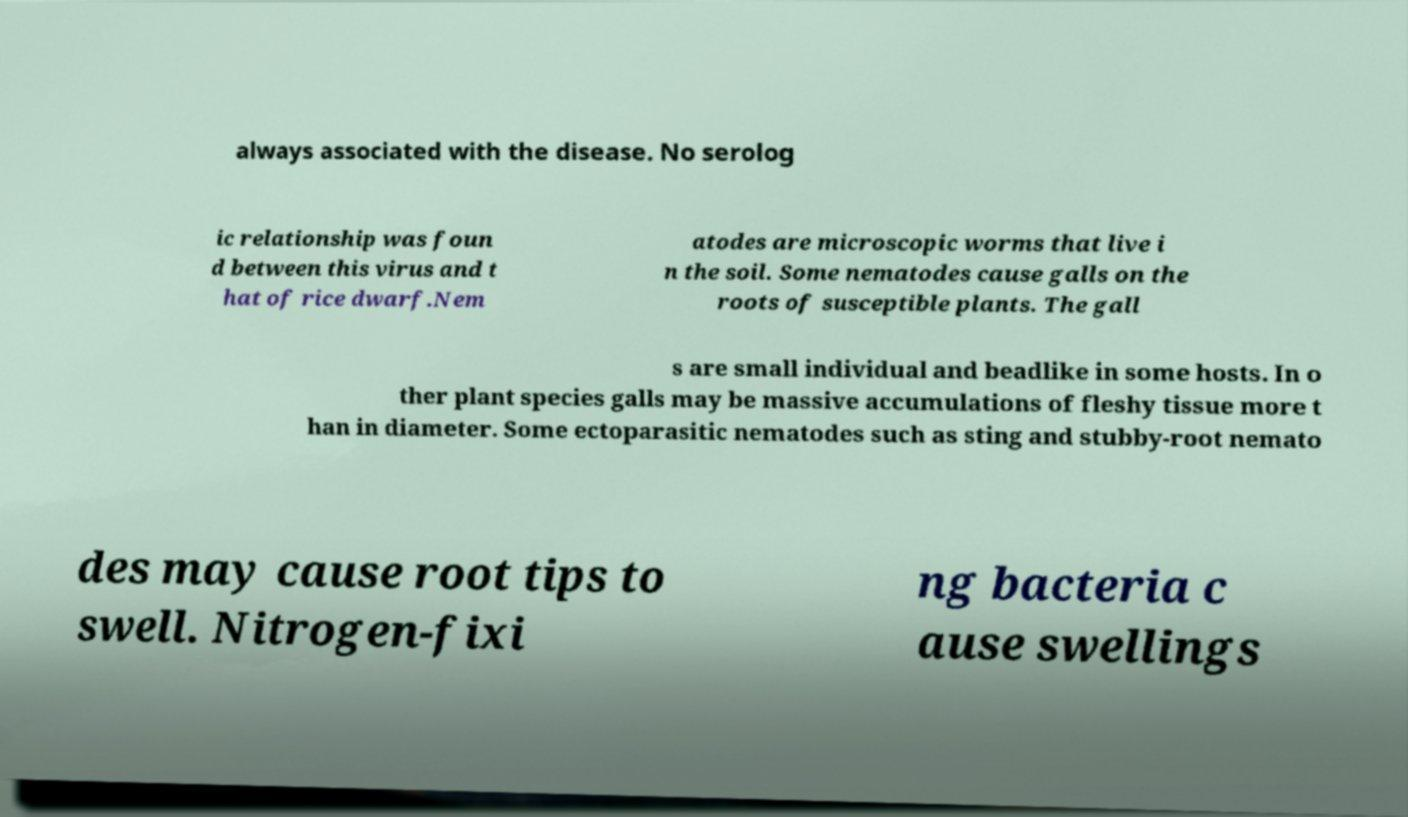Can you read and provide the text displayed in the image?This photo seems to have some interesting text. Can you extract and type it out for me? always associated with the disease. No serolog ic relationship was foun d between this virus and t hat of rice dwarf.Nem atodes are microscopic worms that live i n the soil. Some nematodes cause galls on the roots of susceptible plants. The gall s are small individual and beadlike in some hosts. In o ther plant species galls may be massive accumulations of fleshy tissue more t han in diameter. Some ectoparasitic nematodes such as sting and stubby-root nemato des may cause root tips to swell. Nitrogen-fixi ng bacteria c ause swellings 